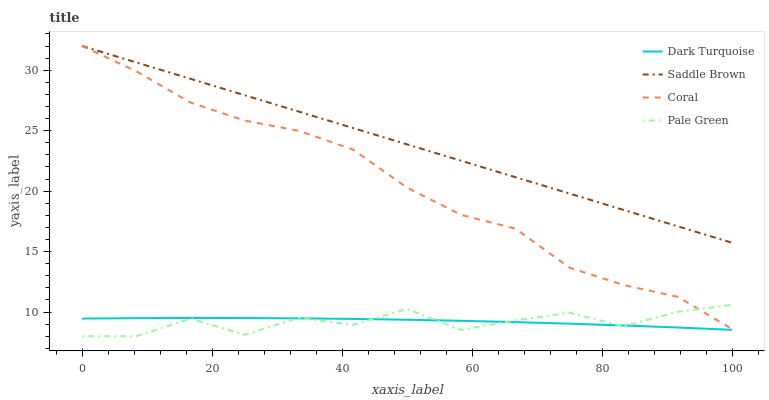Does Pale Green have the minimum area under the curve?
Answer yes or no. Yes. Does Saddle Brown have the maximum area under the curve?
Answer yes or no. Yes. Does Coral have the minimum area under the curve?
Answer yes or no. No. Does Coral have the maximum area under the curve?
Answer yes or no. No. Is Saddle Brown the smoothest?
Answer yes or no. Yes. Is Pale Green the roughest?
Answer yes or no. Yes. Is Coral the smoothest?
Answer yes or no. No. Is Coral the roughest?
Answer yes or no. No. Does Pale Green have the lowest value?
Answer yes or no. Yes. Does Coral have the lowest value?
Answer yes or no. No. Does Saddle Brown have the highest value?
Answer yes or no. Yes. Does Pale Green have the highest value?
Answer yes or no. No. Is Pale Green less than Saddle Brown?
Answer yes or no. Yes. Is Saddle Brown greater than Dark Turquoise?
Answer yes or no. Yes. Does Pale Green intersect Dark Turquoise?
Answer yes or no. Yes. Is Pale Green less than Dark Turquoise?
Answer yes or no. No. Is Pale Green greater than Dark Turquoise?
Answer yes or no. No. Does Pale Green intersect Saddle Brown?
Answer yes or no. No. 